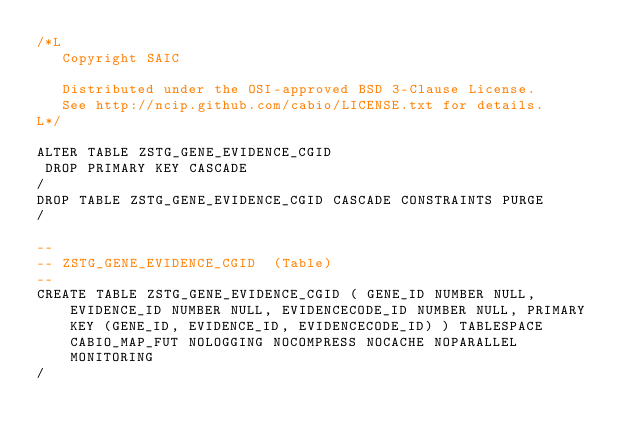Convert code to text. <code><loc_0><loc_0><loc_500><loc_500><_SQL_>/*L
   Copyright SAIC

   Distributed under the OSI-approved BSD 3-Clause License.
   See http://ncip.github.com/cabio/LICENSE.txt for details.
L*/

ALTER TABLE ZSTG_GENE_EVIDENCE_CGID
 DROP PRIMARY KEY CASCADE
/
DROP TABLE ZSTG_GENE_EVIDENCE_CGID CASCADE CONSTRAINTS PURGE
/

--
-- ZSTG_GENE_EVIDENCE_CGID  (Table) 
--
CREATE TABLE ZSTG_GENE_EVIDENCE_CGID ( GENE_ID NUMBER NULL, EVIDENCE_ID NUMBER NULL, EVIDENCECODE_ID NUMBER NULL, PRIMARY KEY (GENE_ID, EVIDENCE_ID, EVIDENCECODE_ID) ) TABLESPACE CABIO_MAP_FUT NOLOGGING NOCOMPRESS NOCACHE NOPARALLEL MONITORING
/


</code> 